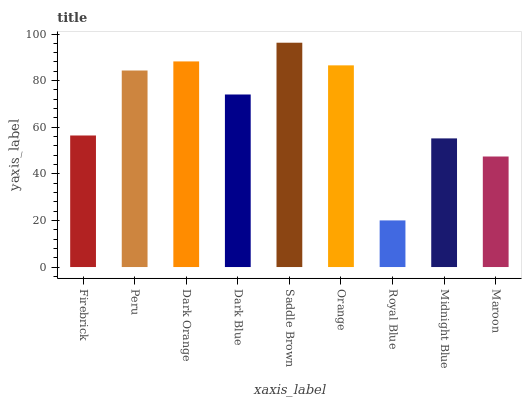Is Royal Blue the minimum?
Answer yes or no. Yes. Is Saddle Brown the maximum?
Answer yes or no. Yes. Is Peru the minimum?
Answer yes or no. No. Is Peru the maximum?
Answer yes or no. No. Is Peru greater than Firebrick?
Answer yes or no. Yes. Is Firebrick less than Peru?
Answer yes or no. Yes. Is Firebrick greater than Peru?
Answer yes or no. No. Is Peru less than Firebrick?
Answer yes or no. No. Is Dark Blue the high median?
Answer yes or no. Yes. Is Dark Blue the low median?
Answer yes or no. Yes. Is Royal Blue the high median?
Answer yes or no. No. Is Firebrick the low median?
Answer yes or no. No. 